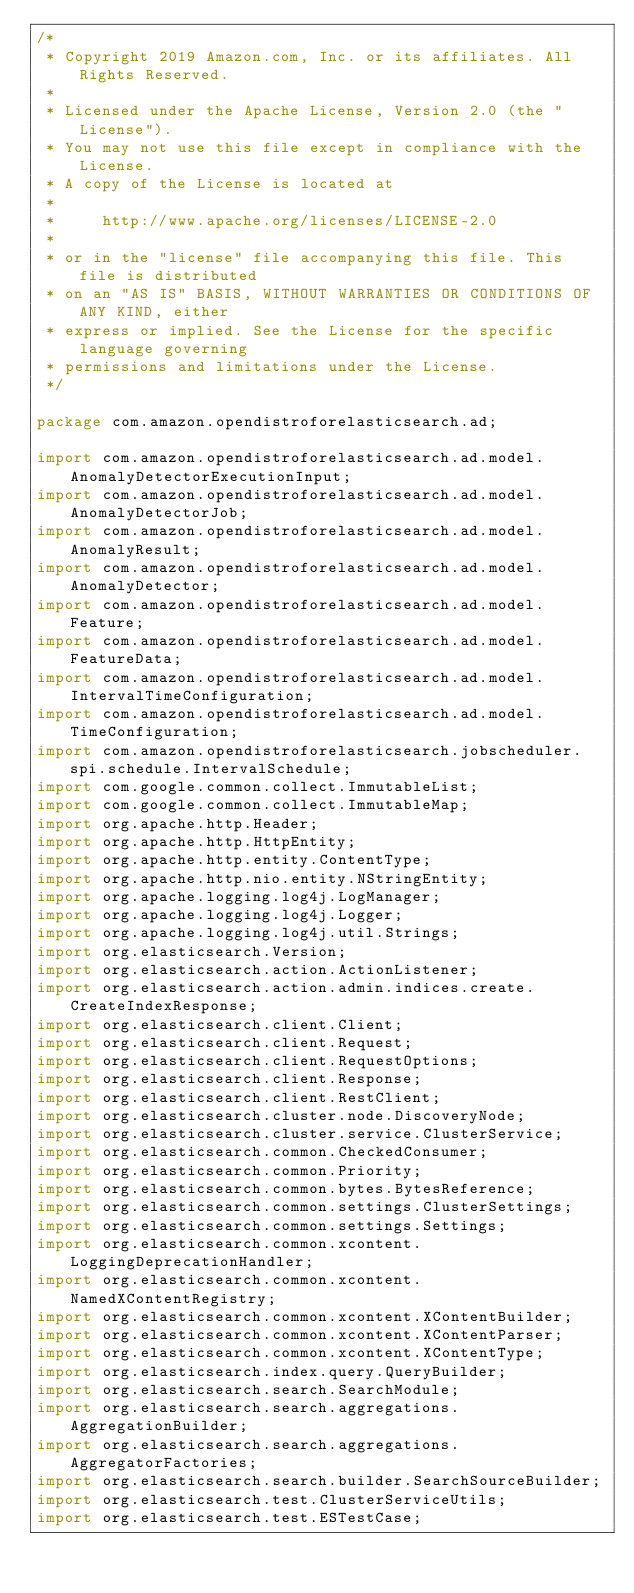Convert code to text. <code><loc_0><loc_0><loc_500><loc_500><_Java_>/*
 * Copyright 2019 Amazon.com, Inc. or its affiliates. All Rights Reserved.
 *
 * Licensed under the Apache License, Version 2.0 (the "License").
 * You may not use this file except in compliance with the License.
 * A copy of the License is located at
 *
 *     http://www.apache.org/licenses/LICENSE-2.0
 *
 * or in the "license" file accompanying this file. This file is distributed
 * on an "AS IS" BASIS, WITHOUT WARRANTIES OR CONDITIONS OF ANY KIND, either
 * express or implied. See the License for the specific language governing
 * permissions and limitations under the License.
 */

package com.amazon.opendistroforelasticsearch.ad;

import com.amazon.opendistroforelasticsearch.ad.model.AnomalyDetectorExecutionInput;
import com.amazon.opendistroforelasticsearch.ad.model.AnomalyDetectorJob;
import com.amazon.opendistroforelasticsearch.ad.model.AnomalyResult;
import com.amazon.opendistroforelasticsearch.ad.model.AnomalyDetector;
import com.amazon.opendistroforelasticsearch.ad.model.Feature;
import com.amazon.opendistroforelasticsearch.ad.model.FeatureData;
import com.amazon.opendistroforelasticsearch.ad.model.IntervalTimeConfiguration;
import com.amazon.opendistroforelasticsearch.ad.model.TimeConfiguration;
import com.amazon.opendistroforelasticsearch.jobscheduler.spi.schedule.IntervalSchedule;
import com.google.common.collect.ImmutableList;
import com.google.common.collect.ImmutableMap;
import org.apache.http.Header;
import org.apache.http.HttpEntity;
import org.apache.http.entity.ContentType;
import org.apache.http.nio.entity.NStringEntity;
import org.apache.logging.log4j.LogManager;
import org.apache.logging.log4j.Logger;
import org.apache.logging.log4j.util.Strings;
import org.elasticsearch.Version;
import org.elasticsearch.action.ActionListener;
import org.elasticsearch.action.admin.indices.create.CreateIndexResponse;
import org.elasticsearch.client.Client;
import org.elasticsearch.client.Request;
import org.elasticsearch.client.RequestOptions;
import org.elasticsearch.client.Response;
import org.elasticsearch.client.RestClient;
import org.elasticsearch.cluster.node.DiscoveryNode;
import org.elasticsearch.cluster.service.ClusterService;
import org.elasticsearch.common.CheckedConsumer;
import org.elasticsearch.common.Priority;
import org.elasticsearch.common.bytes.BytesReference;
import org.elasticsearch.common.settings.ClusterSettings;
import org.elasticsearch.common.settings.Settings;
import org.elasticsearch.common.xcontent.LoggingDeprecationHandler;
import org.elasticsearch.common.xcontent.NamedXContentRegistry;
import org.elasticsearch.common.xcontent.XContentBuilder;
import org.elasticsearch.common.xcontent.XContentParser;
import org.elasticsearch.common.xcontent.XContentType;
import org.elasticsearch.index.query.QueryBuilder;
import org.elasticsearch.search.SearchModule;
import org.elasticsearch.search.aggregations.AggregationBuilder;
import org.elasticsearch.search.aggregations.AggregatorFactories;
import org.elasticsearch.search.builder.SearchSourceBuilder;
import org.elasticsearch.test.ClusterServiceUtils;
import org.elasticsearch.test.ESTestCase;</code> 